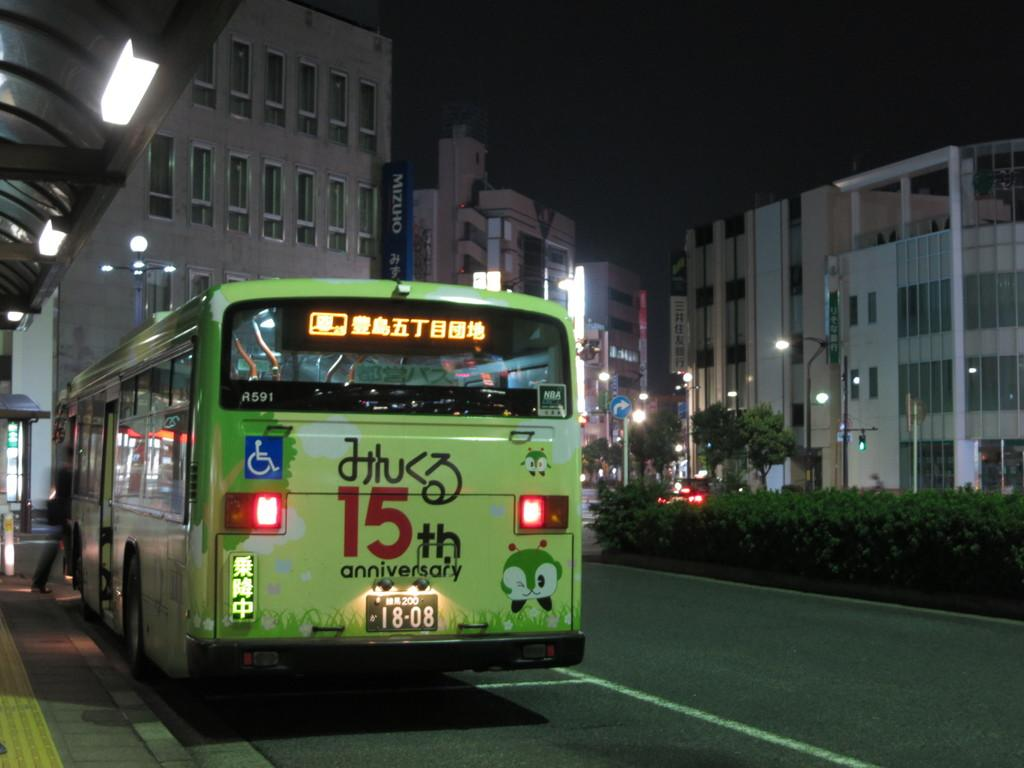<image>
Describe the image concisely. a bus that has the number 15 on it 